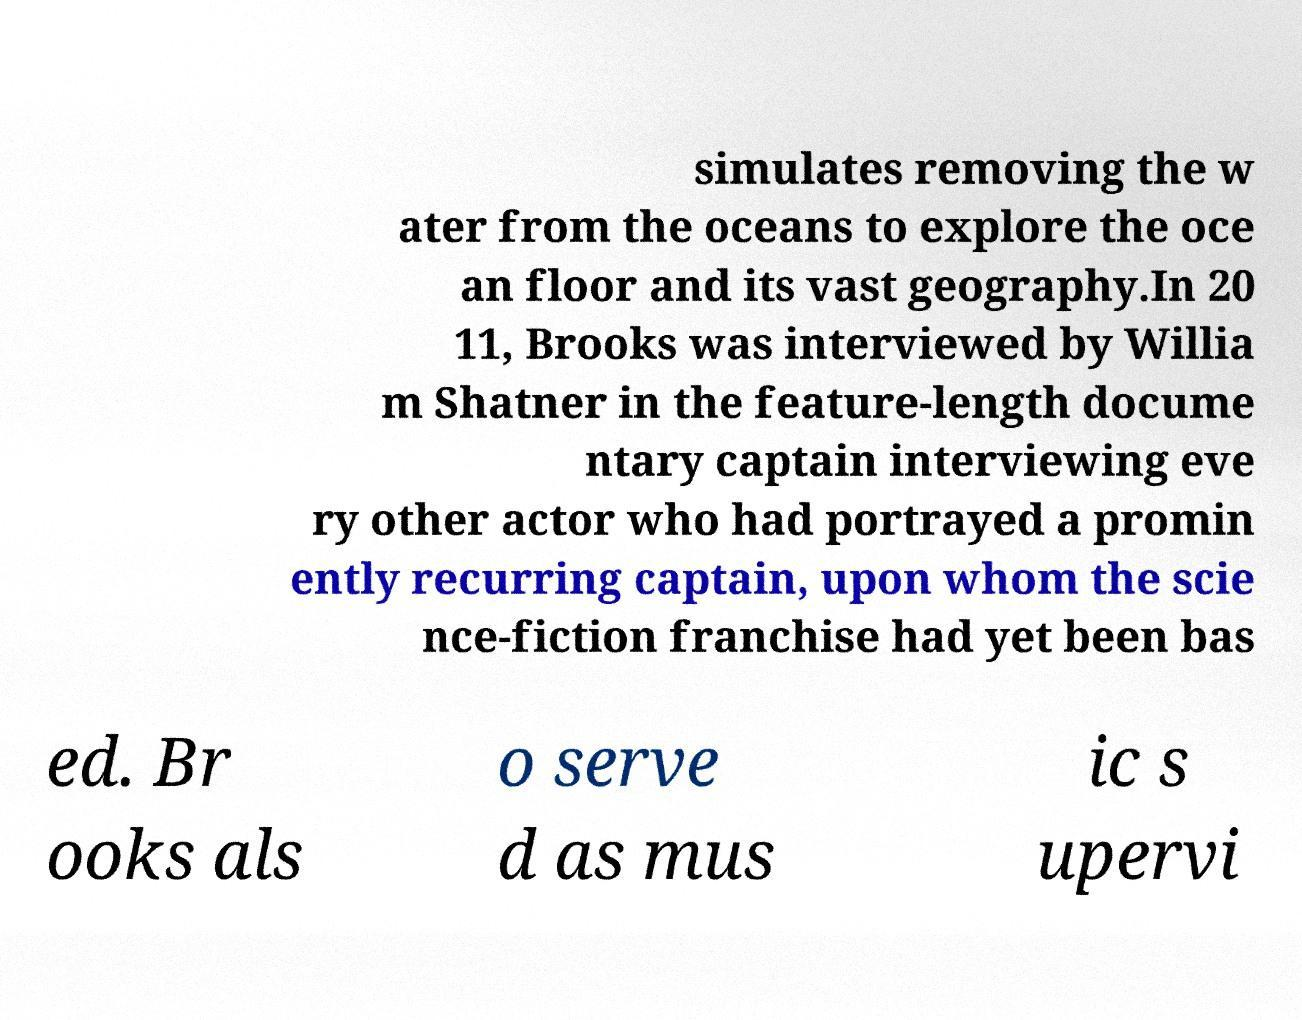Could you assist in decoding the text presented in this image and type it out clearly? simulates removing the w ater from the oceans to explore the oce an floor and its vast geography.In 20 11, Brooks was interviewed by Willia m Shatner in the feature-length docume ntary captain interviewing eve ry other actor who had portrayed a promin ently recurring captain, upon whom the scie nce-fiction franchise had yet been bas ed. Br ooks als o serve d as mus ic s upervi 